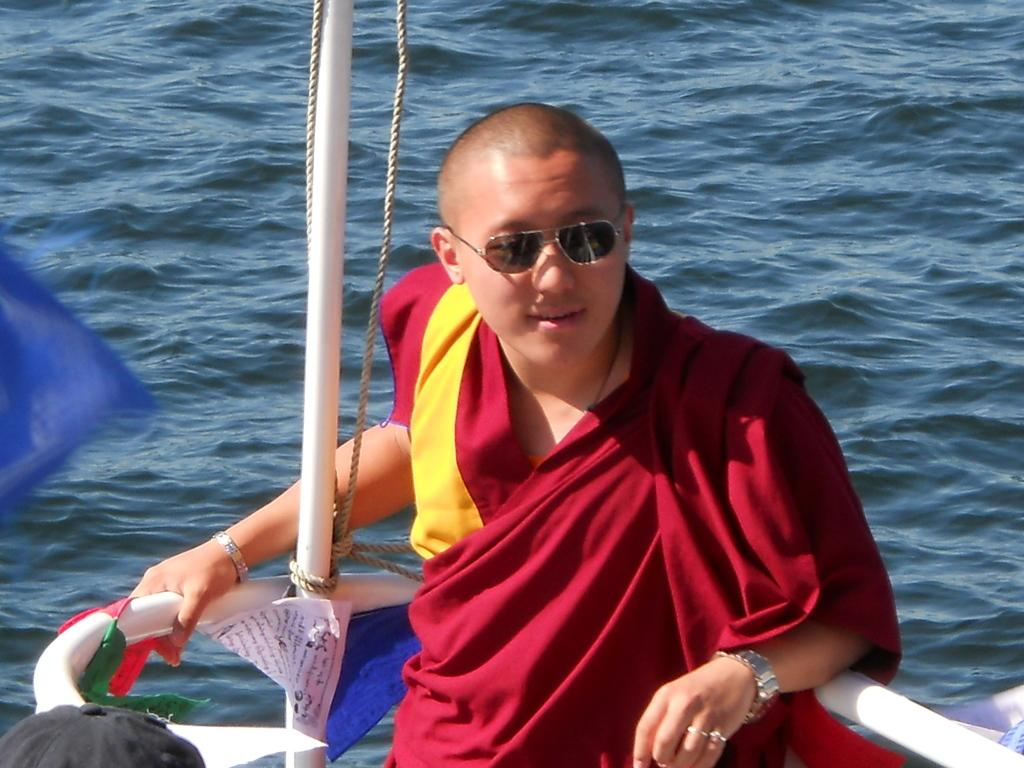What is the main subject of the image? The main subject of the image is a man. Can you describe the man's attire? The man is wearing clothes, a wrist watch, goggles, and a finger ring. What other objects are present in the image? There is a rope, water, a pole, and a cap in the image. What type of flower can be seen growing near the pole in the image? There is no flower present in the image; it features a man wearing goggles, a wrist watch, and a finger ring, along with a rope, water, and a cap. 